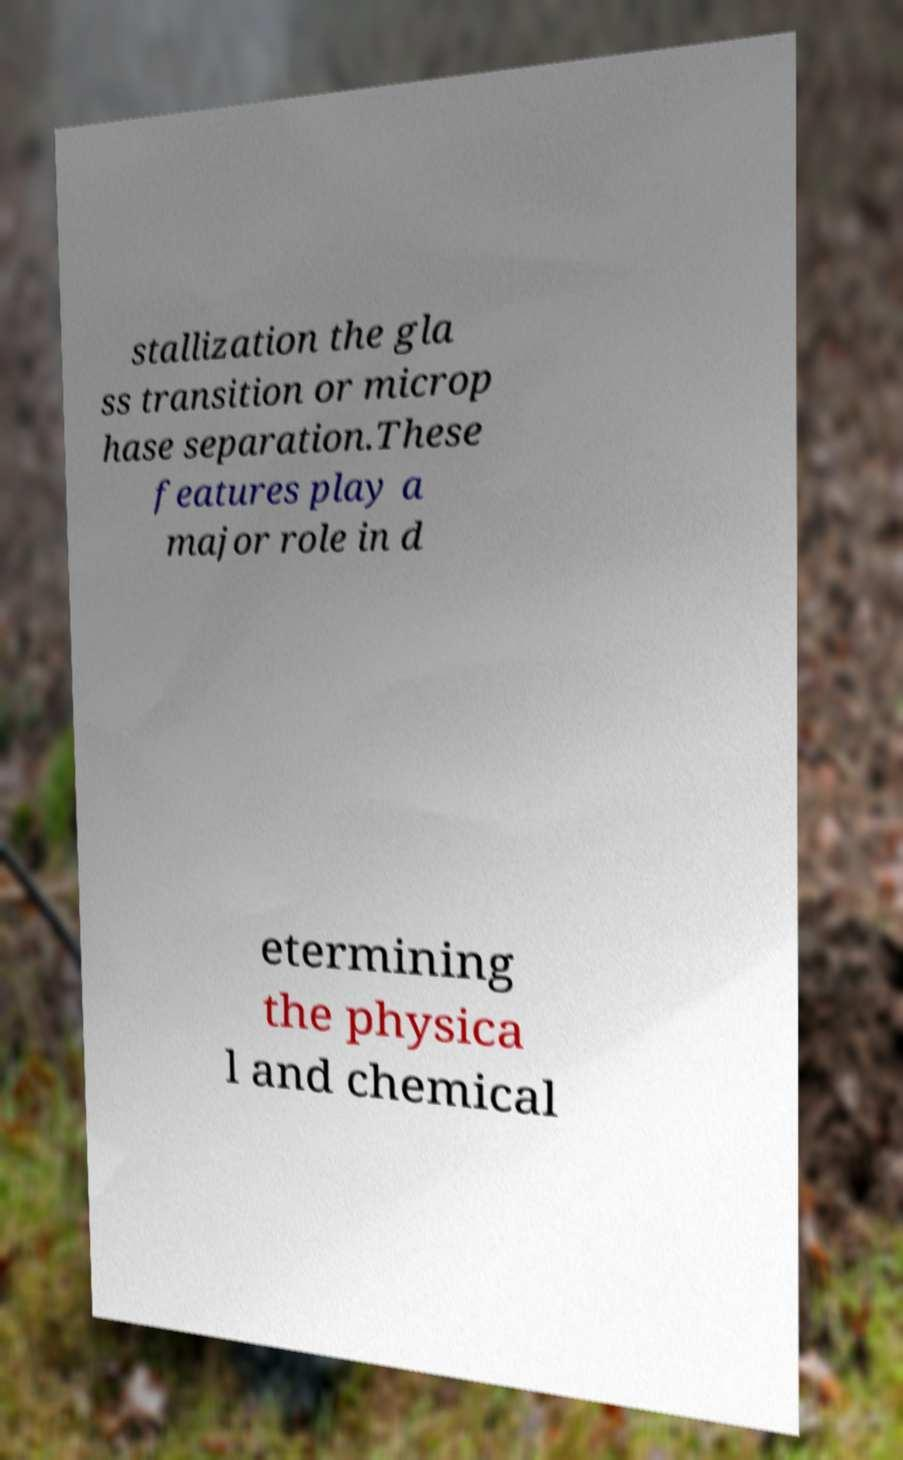Could you extract and type out the text from this image? stallization the gla ss transition or microp hase separation.These features play a major role in d etermining the physica l and chemical 